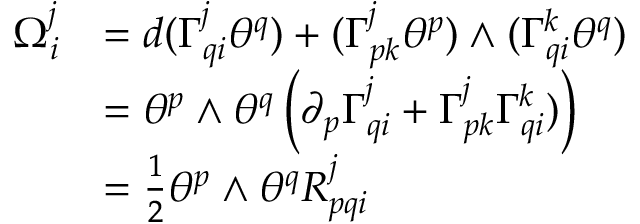<formula> <loc_0><loc_0><loc_500><loc_500>{ \begin{array} { l l } { \Omega _ { i } ^ { j } } & { = d ( \Gamma ^ { j } _ { q i } \theta ^ { q } ) + ( \Gamma ^ { j } _ { p k } \theta ^ { p } ) \wedge ( \Gamma ^ { k } _ { q i } \theta ^ { q } ) } \\ & { = \theta ^ { p } \wedge \theta ^ { q } \left ( \partial _ { p } \Gamma ^ { j } _ { q i } + \Gamma ^ { j } _ { p k } \Gamma ^ { k } _ { q i } ) \right ) } \\ & { = { \frac { 1 } { 2 } } \theta ^ { p } \wedge \theta ^ { q } R _ { p q i } ^ { j } } \end{array} }</formula> 